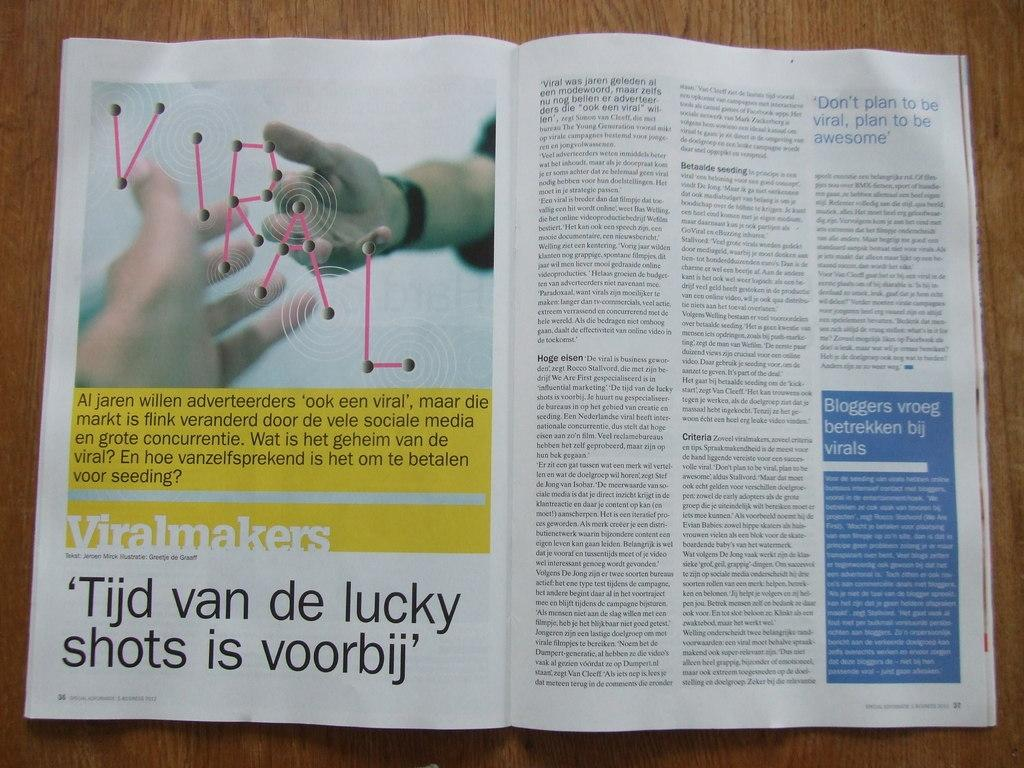<image>
Share a concise interpretation of the image provided. A open book that is written in German language 